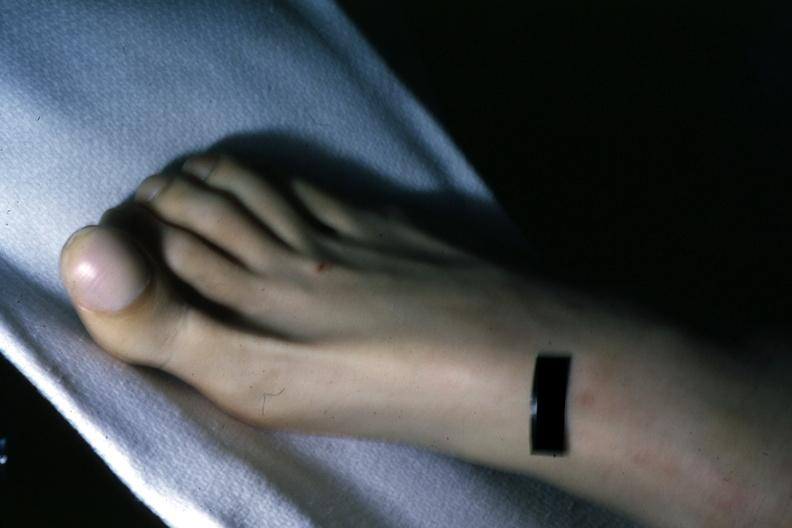re extremities present?
Answer the question using a single word or phrase. Yes 